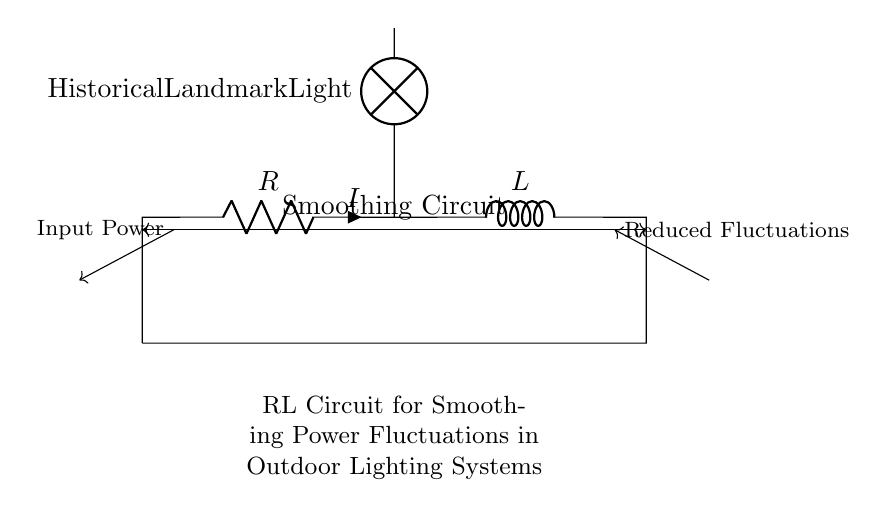What is the role of the resistor in this circuit? The resistor provides resistance, limiting the current flow and thereby helping to dissipate energy as heat. It works along with the inductor to stabilize current fluctuations.
Answer: limiting current What component is labeled as the lamp in this diagram? The component labeled is the "Historical Landmark Light," which represents the outdoor lighting system being smoothed by the circuit.
Answer: Historical Landmark Light What happens to power fluctuations due to this circuit? This circuit smooths out power fluctuations by allowing the inductor to store energy when there is excess current and release it when there is a deficiency.
Answer: Reduced Fluctuations How many main components are in this circuit? There are three main components: one resistor, one inductor, and one lamp.
Answer: three What does the inductor do in this circuit? The inductor stores energy when current is high and releases it when needed, contributing to the smoothing effect on the power fluctuations. This characteristic helps maintain a steady flow of power to the lamp.
Answer: stores energy What type of circuit is this? This is an RL circuit, which consists of a resistor and an inductor. RL circuits are commonly used to manage current changes and stabilize voltage in various electrical applications.
Answer: RL circuit 